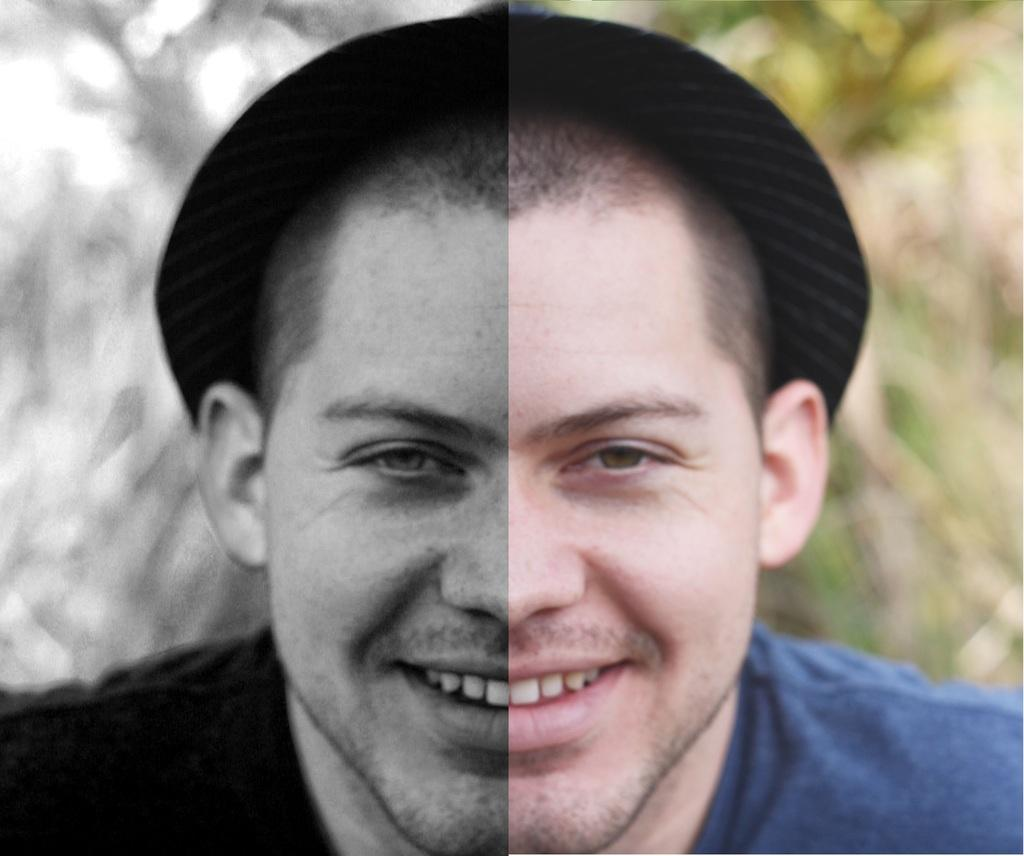Who is the main subject in the image? There is a man in the center of the image. What is the man wearing on his head? The man is wearing a hat. Can you describe the background of the image? There is greenery in the background of the image. How does the image appear to be altered? The image appears to be edited. Where is the baby located in the image? There is no baby present in the image. What type of bat can be seen flying in the background of the image? There is no bat present in the image; it features a man and greenery in the background. 